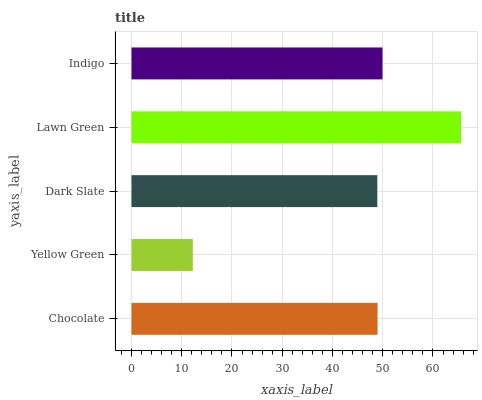Is Yellow Green the minimum?
Answer yes or no. Yes. Is Lawn Green the maximum?
Answer yes or no. Yes. Is Dark Slate the minimum?
Answer yes or no. No. Is Dark Slate the maximum?
Answer yes or no. No. Is Dark Slate greater than Yellow Green?
Answer yes or no. Yes. Is Yellow Green less than Dark Slate?
Answer yes or no. Yes. Is Yellow Green greater than Dark Slate?
Answer yes or no. No. Is Dark Slate less than Yellow Green?
Answer yes or no. No. Is Chocolate the high median?
Answer yes or no. Yes. Is Chocolate the low median?
Answer yes or no. Yes. Is Lawn Green the high median?
Answer yes or no. No. Is Yellow Green the low median?
Answer yes or no. No. 